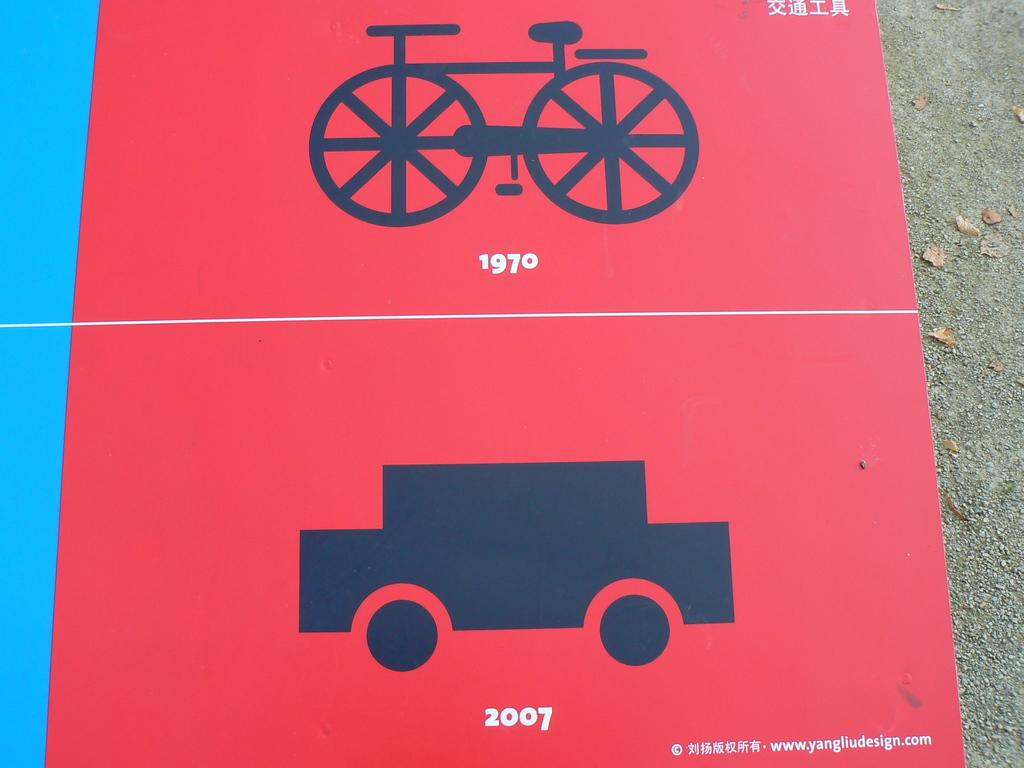What type of image is being described? The image is a poster. What is depicted on the poster? There is a picture of a bicycle and a car on the poster. What type of guitar can be seen hanging from the wing of the car in the image? There is no guitar or wing present on the car in the image; it only features a picture of a car and a bicycle. 